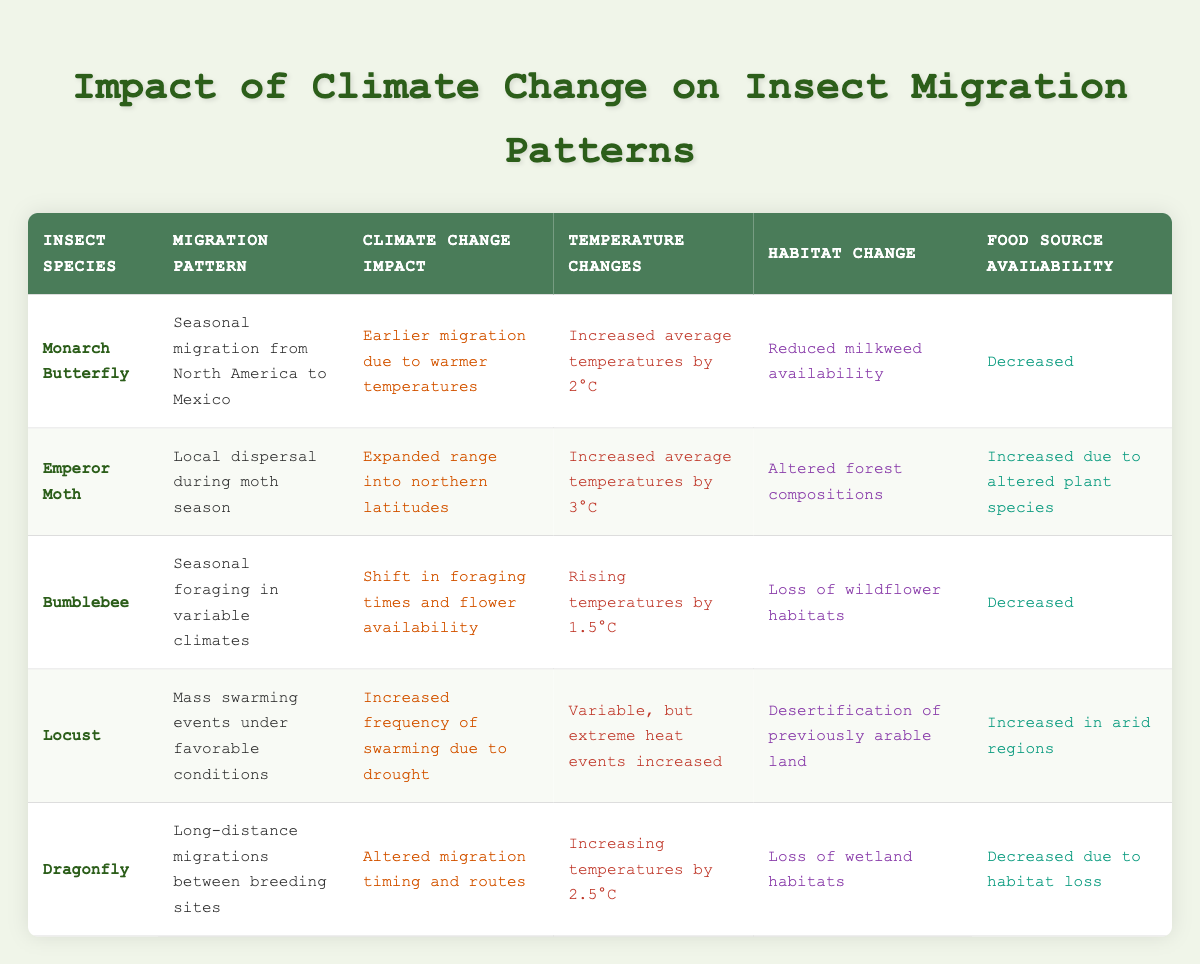What is the migration pattern of the Monarch Butterfly? The table specifies that the Monarch Butterfly exhibits a seasonal migration from North America to Mexico.
Answer: Seasonal migration from North America to Mexico Which insect species has an increased food source availability? In the data, the Emperor Moth is noted for having increased food source availability due to altered plant species.
Answer: Emperor Moth What is the climate change impact experienced by the Bumblebee? The Bumblebee's climate change impact is detailed in the table as a shift in foraging times and flower availability.
Answer: Shift in foraging times and flower availability Are the average temperature changes for the Dragonfly higher than those for the Monarch Butterfly? The Dragonfly has an average temperature increase of 2.5°C, while the Monarch Butterfly has an increase of 2°C. Therefore, the Dragonfly's changes are higher.
Answer: Yes What was the food source availability change for the Locust? The table indicates that the food source availability for the Locust has increased in arid regions due to climate changes.
Answer: Increased in arid regions How many insect species experience a loss of food source availability? Reviewing the table, two species (Bumblebee and Dragonfly) are listed with decreased food source availability.
Answer: 2 Is the migration pattern of the Emperor Moth focused on long-distance movements? The Emperor Moth's migration pattern is shown as local dispersal during the moth season, not long-distance movements.
Answer: No What is the difference in average temperature changes between the Locust and Bumblebee? The Locust has variable temperature changes characterized by extreme heat events, while the Bumblebee's temperature rise is 1.5°C. Since the Locust's impact is not specified as a single degree, we interpret the comparison to show Bumblebee at 1.5°C and conclude that the specific value for Locust cannot be directly quantified as it’s variable. Thus, we answer it in a broader context that Bumblebee's change can be considered as a specific value compared to the unspecified change for Locust.
Answer: Insufficient data for Locust What changes occurred in the habitat of the Dragonfly? According to the table, the Dragonfly's habitat has faced a loss of wetland environments.
Answer: Loss of wetland habitats Which species has the most significant temperature increase recorded? By comparing the temperature changes listed, the Emperor Moth shows the most significant increase at 3°C when contrasted with others.
Answer: Emperor Moth 